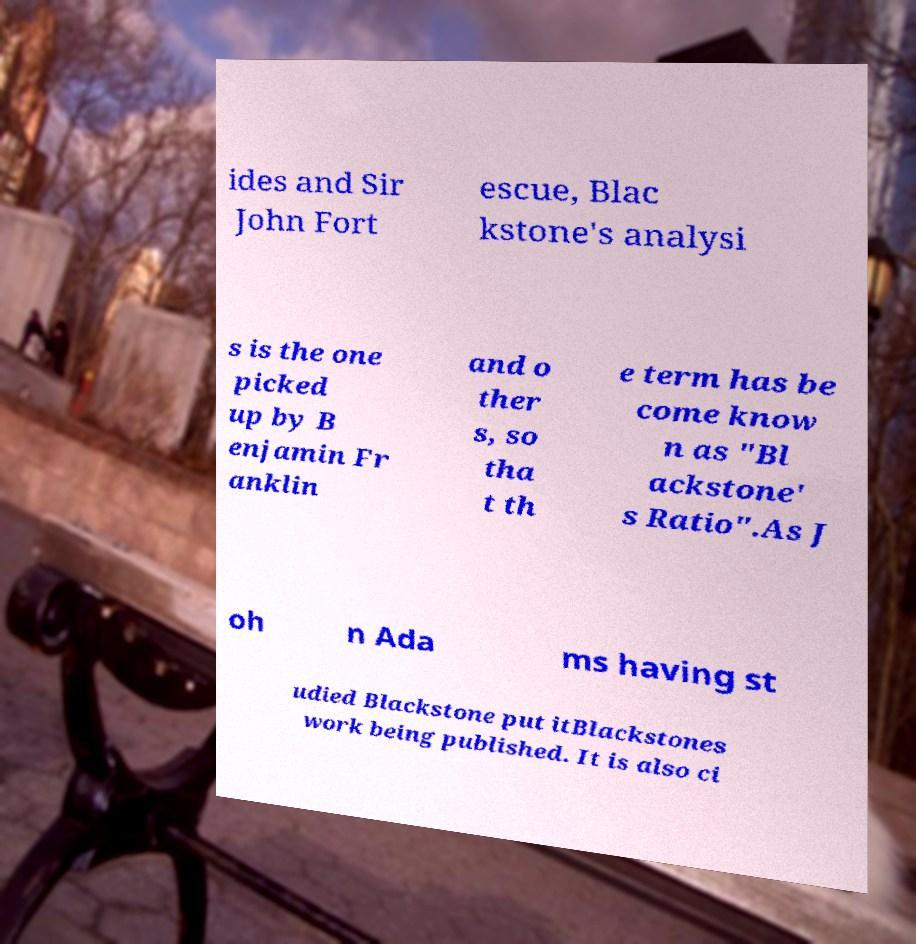Can you accurately transcribe the text from the provided image for me? ides and Sir John Fort escue, Blac kstone's analysi s is the one picked up by B enjamin Fr anklin and o ther s, so tha t th e term has be come know n as "Bl ackstone' s Ratio".As J oh n Ada ms having st udied Blackstone put itBlackstones work being published. It is also ci 